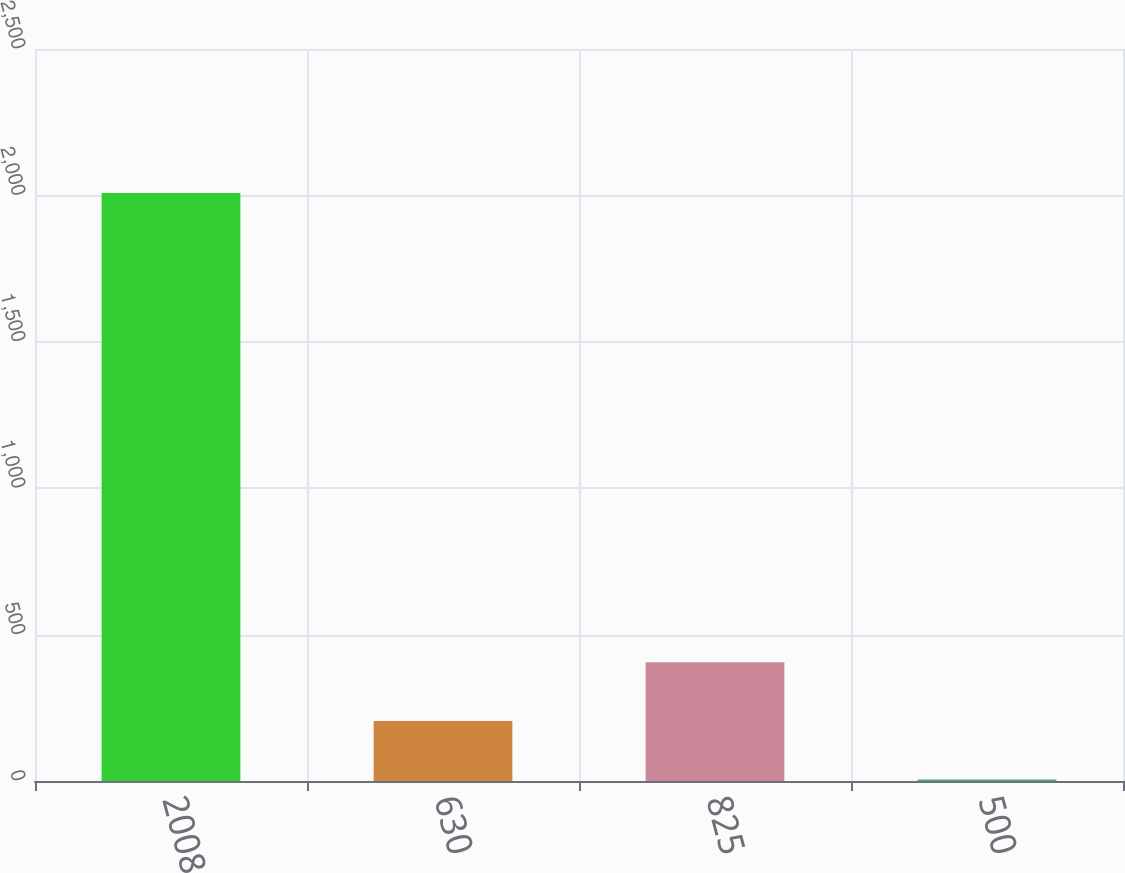<chart> <loc_0><loc_0><loc_500><loc_500><bar_chart><fcel>2008<fcel>630<fcel>825<fcel>500<nl><fcel>2008<fcel>205.3<fcel>405.6<fcel>5<nl></chart> 